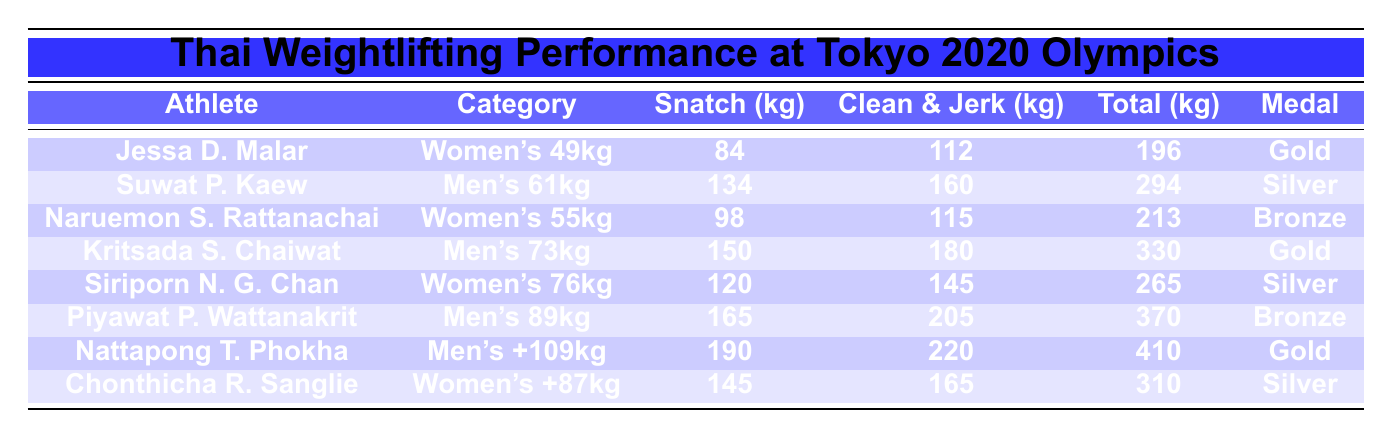What was the highest total weight lifted by a Thai athlete? Nattapong T. Phokha has the highest total weight lifted, which is 410 kg. This is found by comparing the Total column values across all athletes.
Answer: 410 kg Which category did Jessa D. Malar compete in? Jessa D. Malar competed in the Women's 49kg category, as indicated in the Category column next to her name.
Answer: Women's 49kg How many athletes won gold medals? Three athletes won gold medals: Jessa D. Malar, Kritsada S. Chaiwat, and Nattapong T. Phokha. This can be counted by checking the Medal column for the "Gold" entries.
Answer: 3 What is the total weight lifted by Suwat P. Kaew? Suwat P. Kaew lifted a total weight of 294 kg, as stated in the Total column next to his name.
Answer: 294 kg Who had the best Clean and Jerk lift among the Thai athletes? Nattapong T. Phokha had the best Clean and Jerk lift of 220 kg. This is the highest value found in the Clean and Jerk column when compared across all athletes.
Answer: 220 kg How much heavier was Nattapong T. Phokha's total lift compared to Jessa D. Malar's? Nattapong T. Phokha's total lift (410 kg) is 214 kg heavier than Jessa D. Malar's total lift (196 kg), calculated by subtracting 196 from 410.
Answer: 214 kg Did any Thai athlete not win a medal? No, all Thai athletes listed in the table won medals; this can be confirmed by reviewing the Medal column, where every entry is filled.
Answer: No What is the average Snatch weight lifted by the Thai athletes? The average Snatch weight is calculated by summing the Snatch values (84 + 134 + 98 + 150 + 120 + 165 + 190 + 145 = 1086 kg) and dividing by the number of athletes (8), resulting in an average of 1086/8 = 135.75 kg.
Answer: 135.75 kg Which athlete lifted the least in the Snatch category? Jessa D. Malar lifted the least in the Snatch category with 84 kg, as it is the minimum value found in the Snatch column.
Answer: 84 kg How many athletes won medals in the men's categories? Four athletes won medals in the men's categories: Suwat P. Kaew (Silver), Kritsada S. Chaiwat (Gold), Piyawat P. Wattanakrit (Bronze), and Nattapong T. Phokha (Gold). This total is derived from counting the medals listed for the male athletes in the table.
Answer: 4 